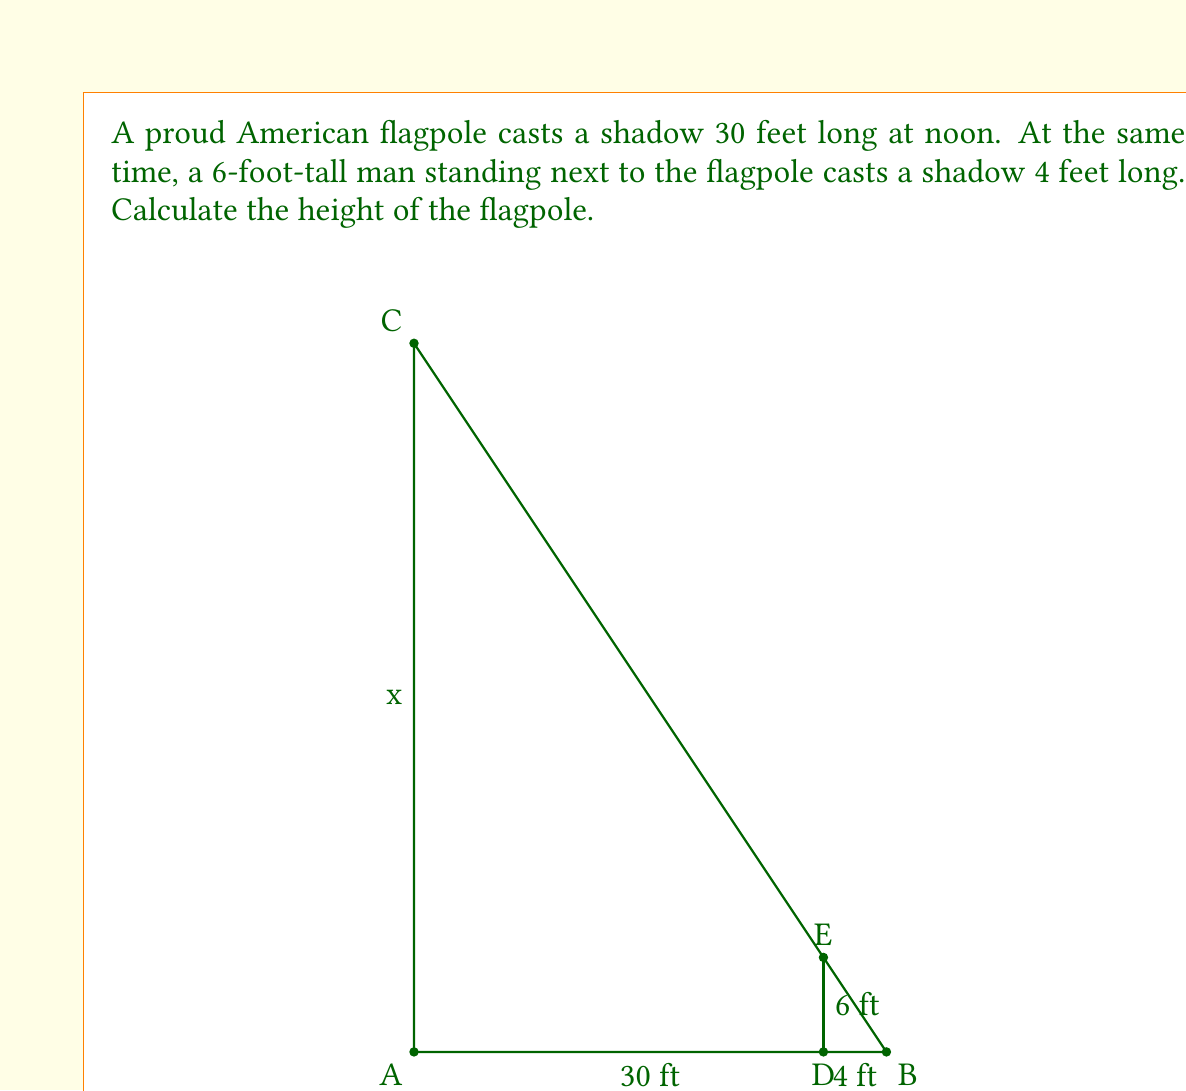Could you help me with this problem? Let's solve this step-by-step using the principle of similar triangles:

1) The flagpole and the man form similar triangles with their shadows because they are both illuminated by the same light source (the sun) at the same angle.

2) Let the height of the flagpole be $x$ feet.

3) For the man, we have:
   $\frac{\text{height}}{\text{shadow length}} = \frac{6}{4} = 1.5$

4) Due to similar triangles, this ratio will be the same for the flagpole:
   $\frac{x}{30} = 1.5$

5) We can solve this equation for $x$:
   $x = 30 \times 1.5 = 45$

6) Therefore, the height of the flagpole is 45 feet.

This method uses the concept of similar triangles, where corresponding sides are proportional. The ratio of height to shadow length is constant for objects illuminated by the same light source at the same angle.
Answer: $45$ feet 